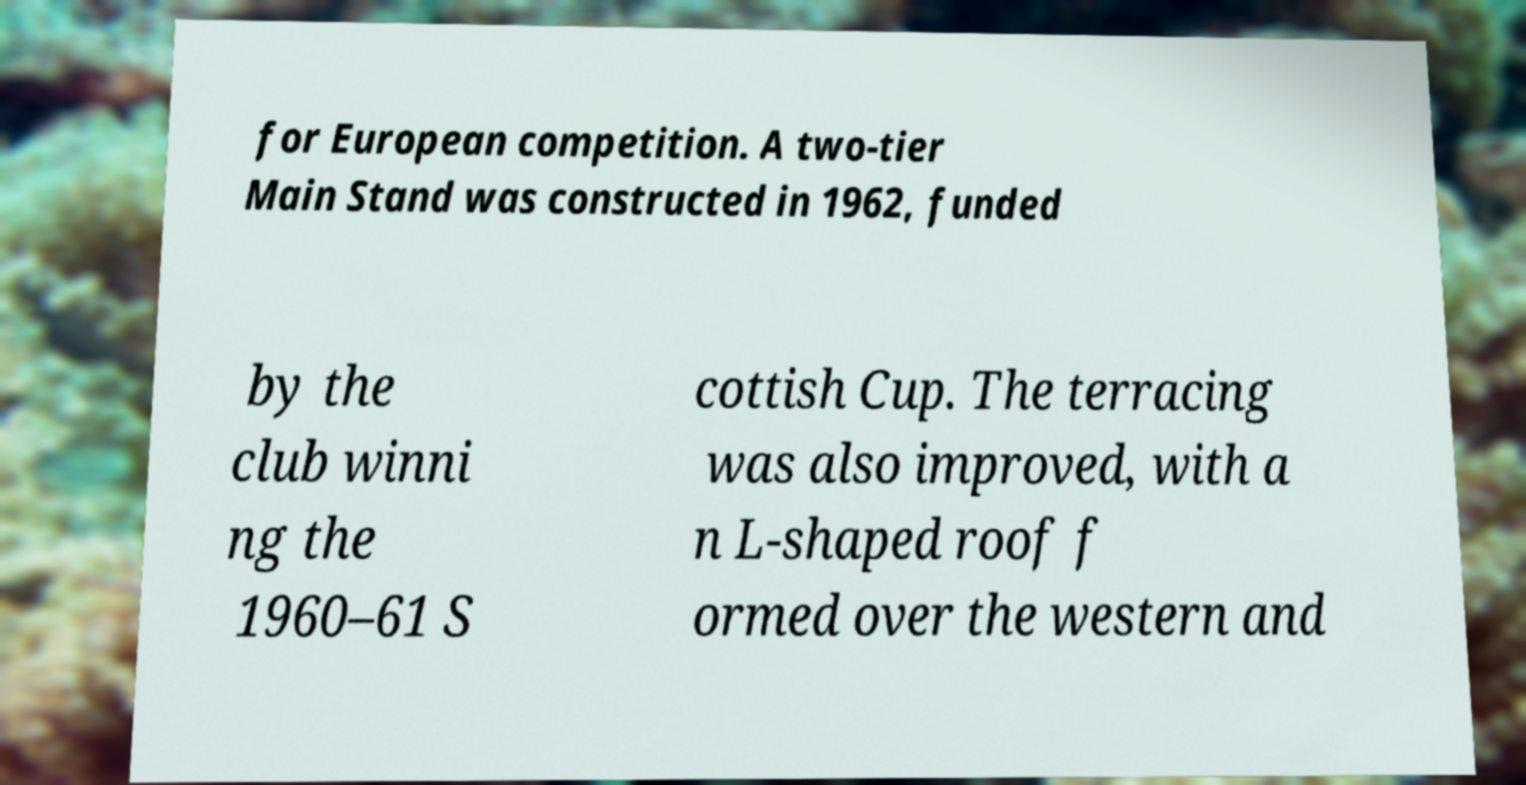Please read and relay the text visible in this image. What does it say? for European competition. A two-tier Main Stand was constructed in 1962, funded by the club winni ng the 1960–61 S cottish Cup. The terracing was also improved, with a n L-shaped roof f ormed over the western and 